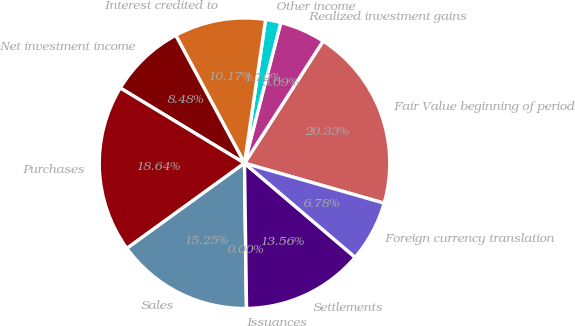Convert chart. <chart><loc_0><loc_0><loc_500><loc_500><pie_chart><fcel>Fair Value beginning of period<fcel>Realized investment gains<fcel>Other income<fcel>Interest credited to<fcel>Net investment income<fcel>Purchases<fcel>Sales<fcel>Issuances<fcel>Settlements<fcel>Foreign currency translation<nl><fcel>20.33%<fcel>5.09%<fcel>1.7%<fcel>10.17%<fcel>8.48%<fcel>18.64%<fcel>15.25%<fcel>0.0%<fcel>13.56%<fcel>6.78%<nl></chart> 